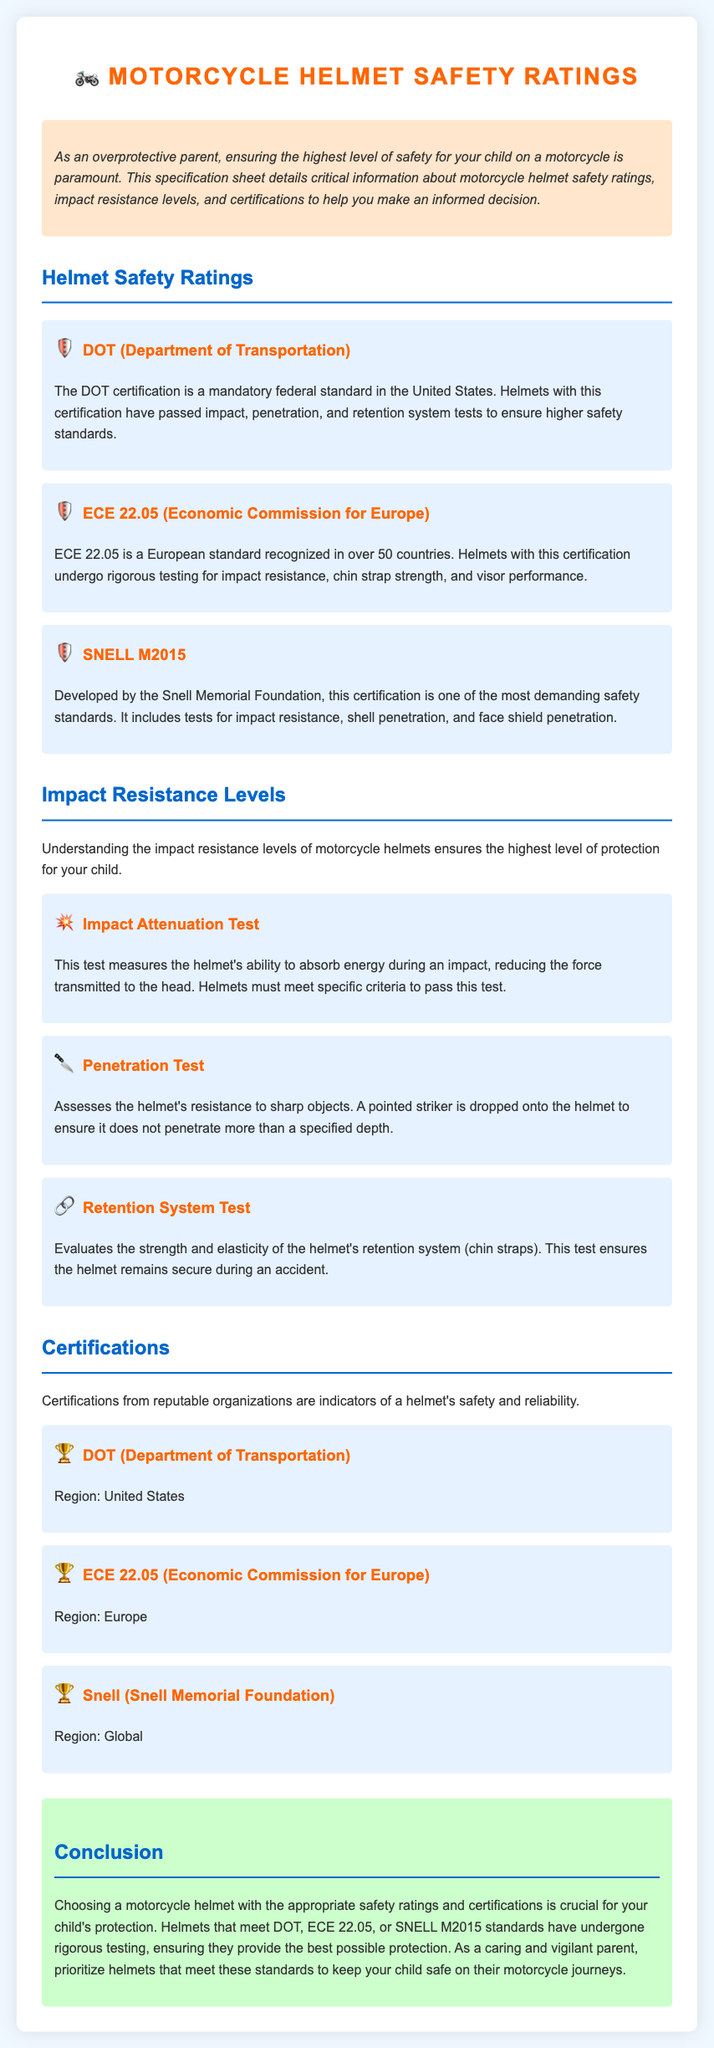What is the first certification listed? The first certification mentioned under Helmet Safety Ratings is DOT (Department of Transportation).
Answer: DOT (Department of Transportation) How many safety ratings are mentioned in total? The document lists three safety ratings: DOT, ECE 22.05, and SNELL M2015.
Answer: Three What test assesses the helmet's resistance to sharp objects? The document specifies that the Penetration Test assesses resistance to sharp objects.
Answer: Penetration Test What is the testing standard developed by the Snell Memorial Foundation? The document states that the testing standard is SNELL M2015.
Answer: SNELL M2015 Which certification is recognized in over 50 countries? The certification recognized in over 50 countries is ECE 22.05.
Answer: ECE 22.05 What is the purpose of the Retention System Test? The Retention System Test evaluates the strength and elasticity of the helmet's retention system.
Answer: Retention System Test Which regions are covered by the DOT certification? The DOT certification is specific to the United States.
Answer: United States What color is used for the headings in the document? The headings are colored in dark blue.
Answer: Dark blue 